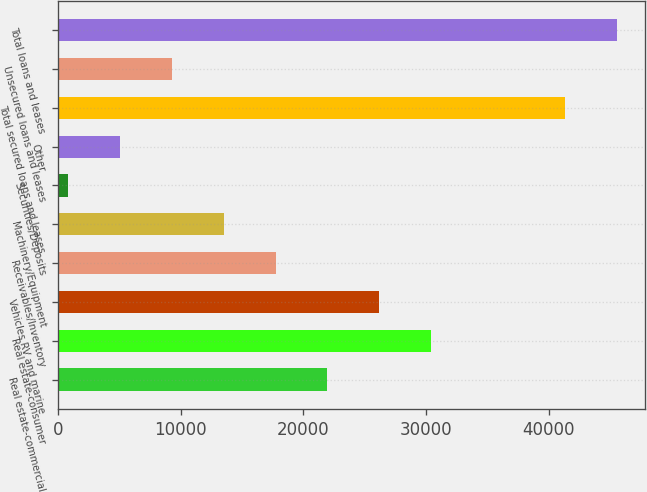Convert chart to OTSL. <chart><loc_0><loc_0><loc_500><loc_500><bar_chart><fcel>Real estate-commercial<fcel>Real estate-consumer<fcel>Vehicles RV and marine<fcel>Receivables/Inventory<fcel>Machinery/Equipment<fcel>Securities/Deposits<fcel>Other<fcel>Total secured loans and leases<fcel>Unsecured loans and leases<fcel>Total loans and leases<nl><fcel>21953<fcel>30419.8<fcel>26186.4<fcel>17719.6<fcel>13486.2<fcel>786<fcel>5019.4<fcel>41342<fcel>9252.8<fcel>45575.4<nl></chart> 